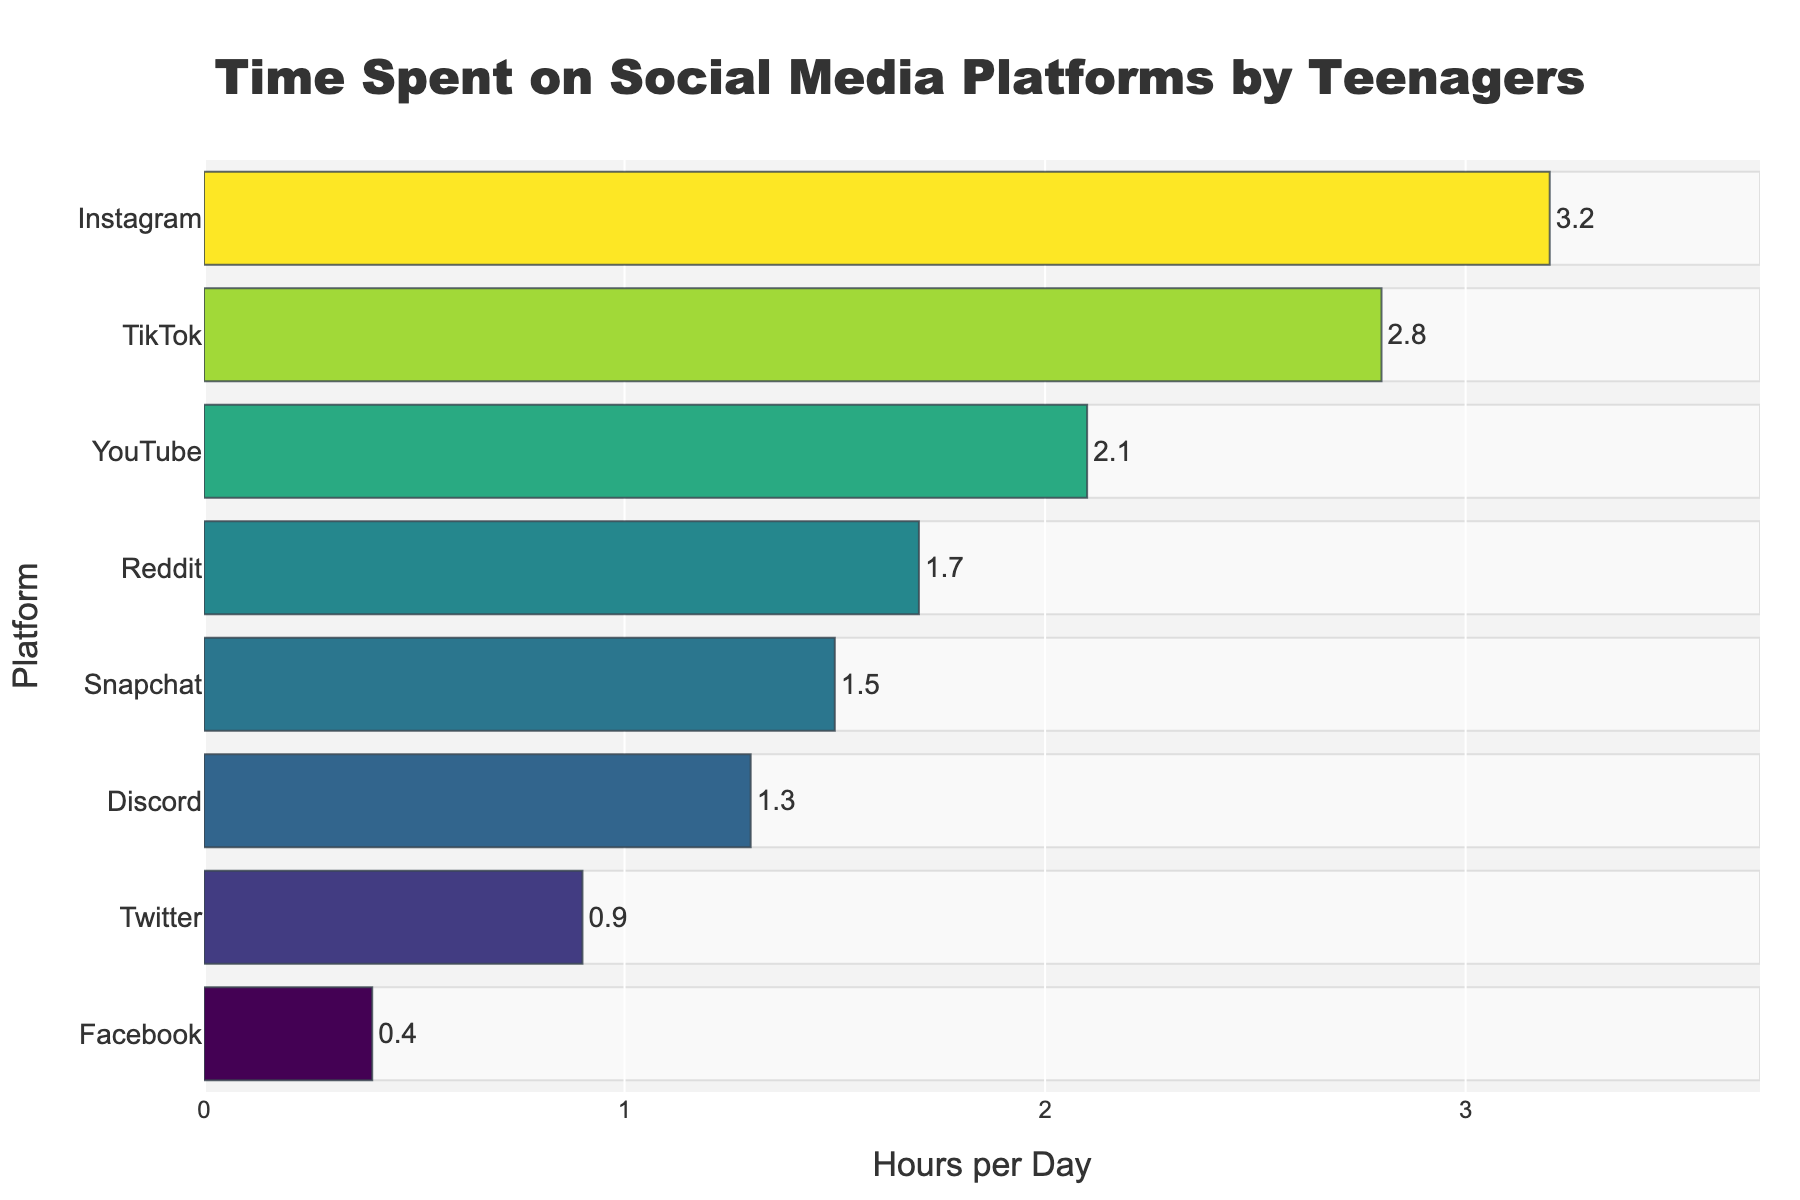What is the title of the figure? The title is usually located at the very top of the chart. This chart has the title in large, bold letters.
Answer: Time Spent on Social Media Platforms by Teenagers Which social media platform do teenagers spend the most time on? By looking at the length of the bars, the longest bar represents the platform with the highest hours per day.
Answer: Instagram What is the total time spent across all platforms? Summing up all the values of hours per day for each platform gives the total time. 3.2 + 2.8 + 1.5 + 2.1 + 0.9 + 0.4 + 1.7 + 1.3 = 13.9
Answer: 13.9 hours Which platform do teenagers spend the least time on? The shortest bar represents the platform with the lowest hours per day.
Answer: Facebook How much more time do teenagers spend on Instagram compared to Twitter? Find the difference between the hours spent on Instagram and Twitter by subtracting Twitter's value from Instagram's. 3.2 - 0.9 = 2.3
Answer: 2.3 hours What is the average time spent on YouTube and Snapchat? Add the hours per day for YouTube and Snapchat and then divide by 2. (2.1 + 1.5) / 2 = 1.8
Answer: 1.8 hours List the platforms where teenagers spend more than 2 hours a day. Identify platforms with bars extending beyond the 2-hour mark.
Answer: Instagram, TikTok How much time do teenagers spend on Reddit and Discord combined? Add the hours per day for Reddit and Discord together. 1.7 + 1.3 = 3
Answer: 3 hours Rank the platforms from highest to lowest based on time spent. Order the platforms according to the length of the bars from longest to shortest.
Answer: Instagram, TikTok, YouTube, Reddit, Snapchat, Discord, Twitter, Facebook What is the average time spent per platform? Calculate the average by summing all hours per day and dividing by the number of platforms. (3.2 + 2.8 + 1.5 + 2.1 + 0.9 + 0.4 + 1.7 + 1.3) / 8 = 1.7375
Answer: 1.7375 hours 